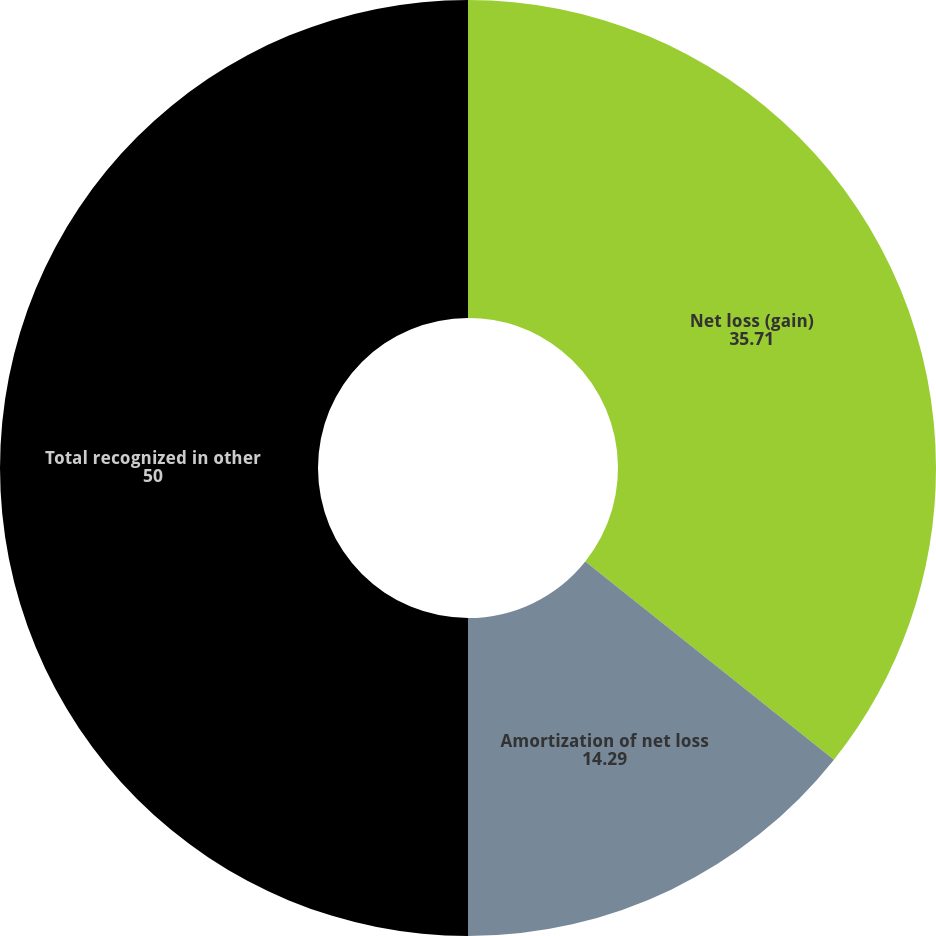<chart> <loc_0><loc_0><loc_500><loc_500><pie_chart><fcel>Net loss (gain)<fcel>Amortization of net loss<fcel>Total recognized in other<nl><fcel>35.71%<fcel>14.29%<fcel>50.0%<nl></chart> 